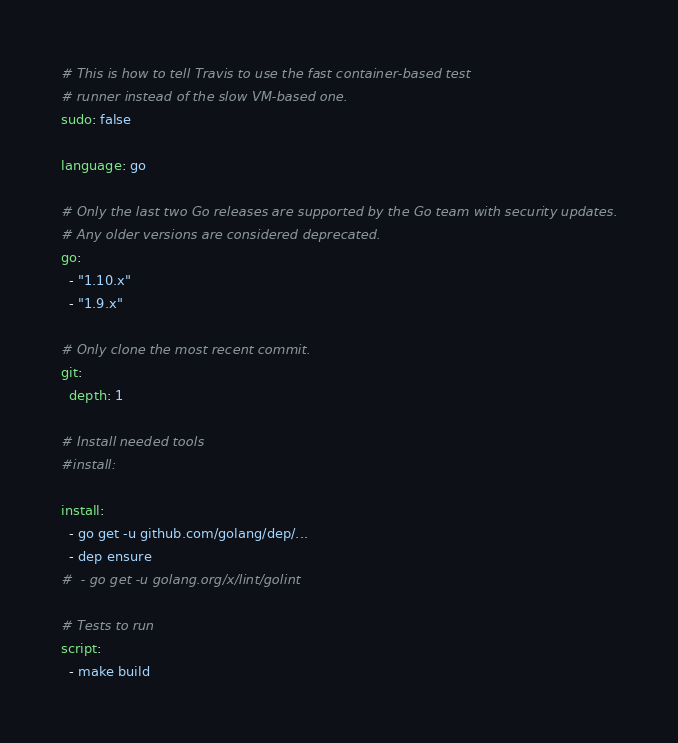Convert code to text. <code><loc_0><loc_0><loc_500><loc_500><_YAML_># This is how to tell Travis to use the fast container-based test
# runner instead of the slow VM-based one.
sudo: false

language: go

# Only the last two Go releases are supported by the Go team with security updates.
# Any older versions are considered deprecated.
go:
  - "1.10.x"
  - "1.9.x"

# Only clone the most recent commit.
git:
  depth: 1

# Install needed tools
#install:

install:
  - go get -u github.com/golang/dep/...
  - dep ensure
#  - go get -u golang.org/x/lint/golint

# Tests to run
script:
  - make build
</code> 